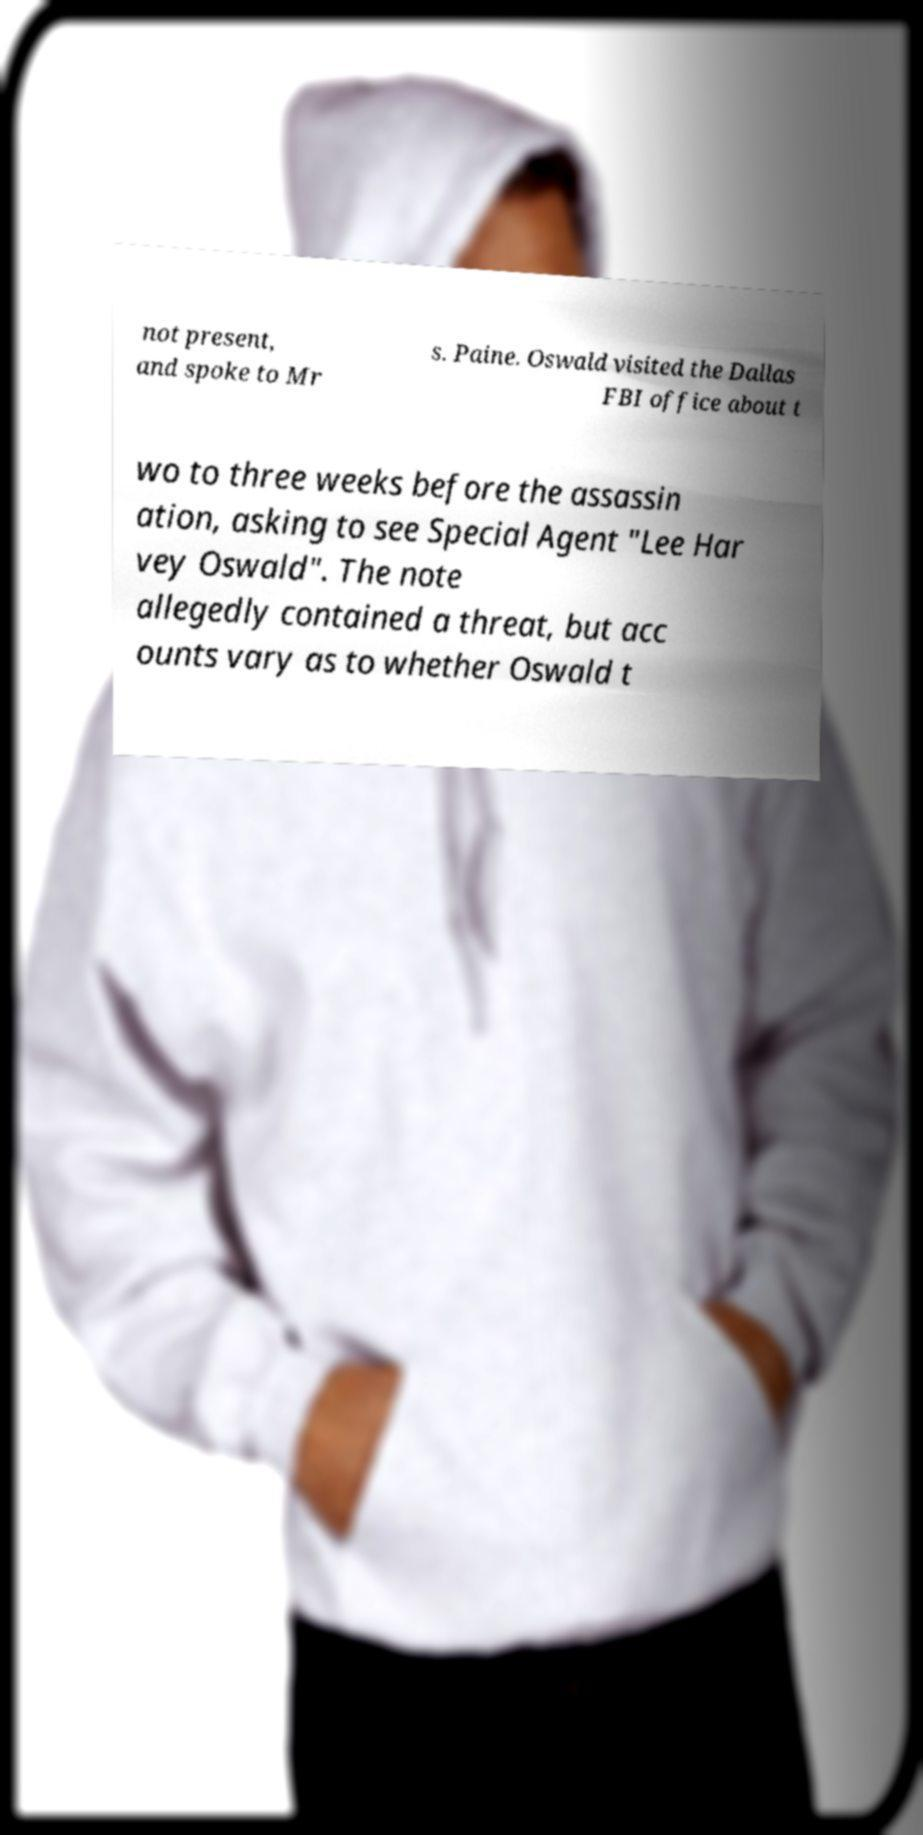What messages or text are displayed in this image? I need them in a readable, typed format. not present, and spoke to Mr s. Paine. Oswald visited the Dallas FBI office about t wo to three weeks before the assassin ation, asking to see Special Agent "Lee Har vey Oswald". The note allegedly contained a threat, but acc ounts vary as to whether Oswald t 